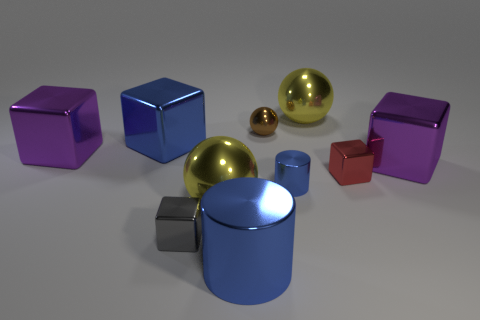What number of objects are big blue matte balls or yellow balls right of the large blue cylinder?
Offer a terse response. 1. What color is the tiny sphere that is the same material as the gray block?
Provide a short and direct response. Brown. How many gray cubes have the same material as the small brown ball?
Your response must be concise. 1. How many metallic cylinders are there?
Keep it short and to the point. 2. There is a metallic cylinder that is behind the small gray metallic block; is its color the same as the shiny ball that is behind the brown object?
Your answer should be compact. No. What number of blue things are behind the small shiny cylinder?
Your response must be concise. 1. There is a big block that is the same color as the tiny cylinder; what material is it?
Keep it short and to the point. Metal. Is there a yellow object of the same shape as the tiny brown metallic object?
Your response must be concise. Yes. Is the small thing that is on the left side of the big cylinder made of the same material as the large purple object that is on the left side of the gray cube?
Offer a terse response. Yes. What is the size of the blue thing that is in front of the yellow thing that is to the left of the large yellow ball that is behind the brown shiny ball?
Make the answer very short. Large. 